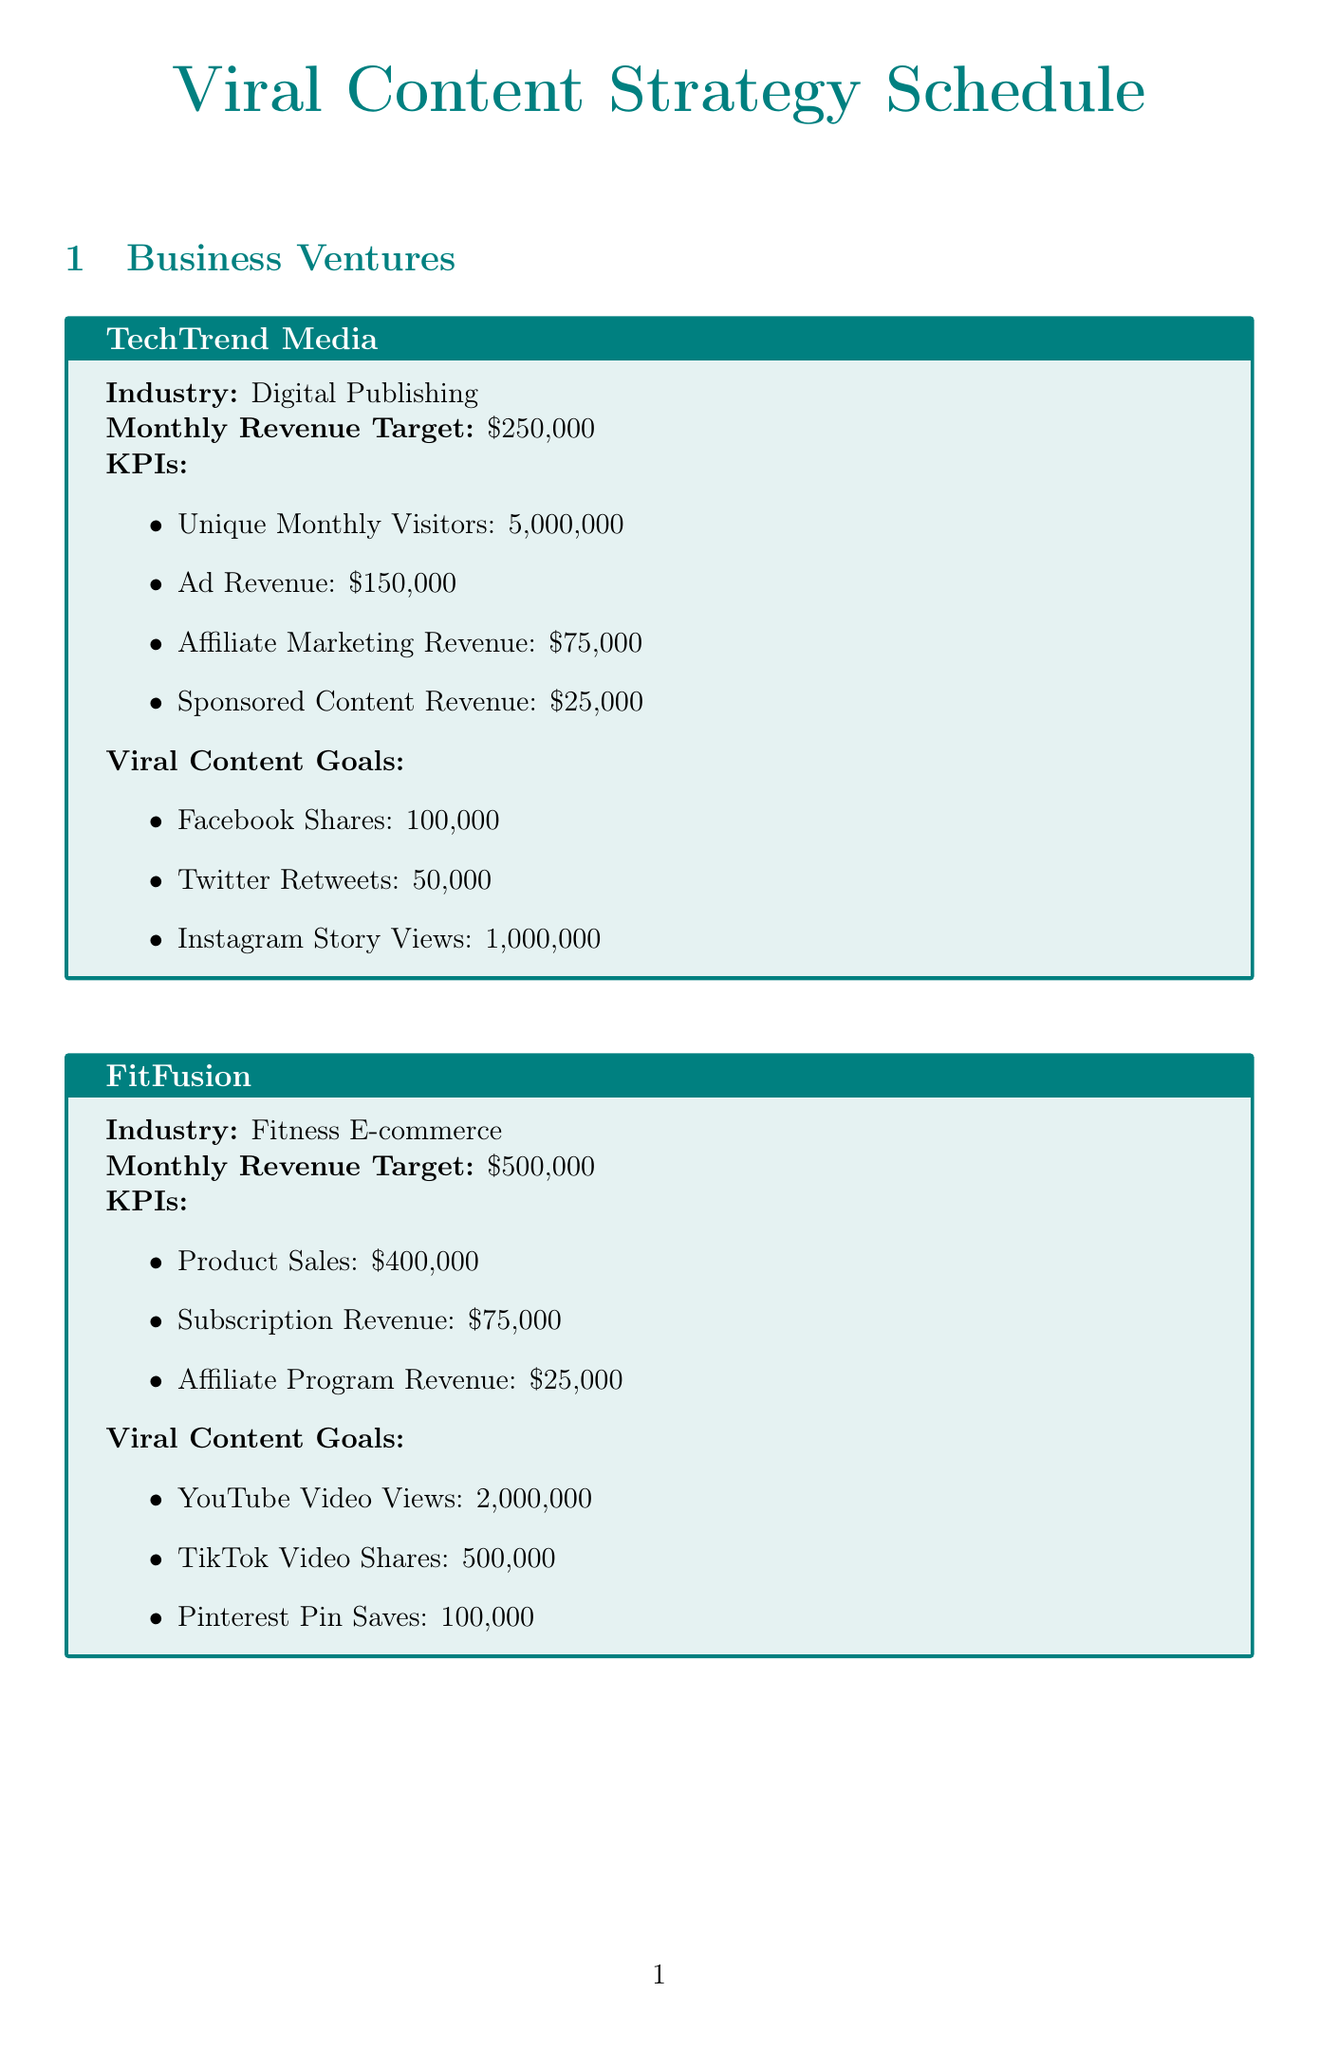what is the monthly revenue target for TechTrend Media? The monthly revenue target is specified for TechTrend Media in the document.
Answer: $250,000 how many unique monthly visitors does FitFusion aim for? The document states the target for unique monthly visitors for each business, specifically for FitFusion.
Answer: Not specified what is the target for Instagram Story Views for TechTrend Media? The document lists the viral content goals for TechTrend Media, including the Instagram Story Views target.
Answer: 1,000,000 which platform has a target of 500,000 video shares? The document includes viral content goals, showing the platform and target for video shares.
Answer: TikTok how often are live Q&A sessions scheduled? The document specifies the frequency of content creation strategies, including live Q&A sessions.
Answer: Monthly what is the KPI for online course enrollments for GreenGrowth? The document outlines the KPIs for each business, providing specific targets, including for online course enrollments.
Answer: $75,000 which business venture has the highest monthly revenue target? The revenue targets for each business venture are compared in the document, identifying the one with the highest target.
Answer: FitFusion what is the purpose of Hootsuite as per the document? The document lists the performance tracking tools along with their purposes.
Answer: Social media management and analytics 